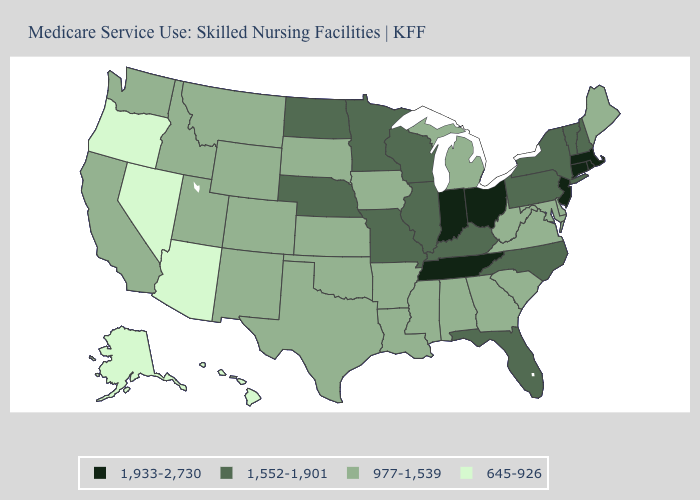Name the states that have a value in the range 1,933-2,730?
Write a very short answer. Connecticut, Indiana, Massachusetts, New Jersey, Ohio, Rhode Island, Tennessee. What is the value of Pennsylvania?
Concise answer only. 1,552-1,901. What is the value of Missouri?
Concise answer only. 1,552-1,901. How many symbols are there in the legend?
Concise answer only. 4. Does Illinois have the same value as Kentucky?
Give a very brief answer. Yes. How many symbols are there in the legend?
Keep it brief. 4. Name the states that have a value in the range 977-1,539?
Give a very brief answer. Alabama, Arkansas, California, Colorado, Delaware, Georgia, Idaho, Iowa, Kansas, Louisiana, Maine, Maryland, Michigan, Mississippi, Montana, New Mexico, Oklahoma, South Carolina, South Dakota, Texas, Utah, Virginia, Washington, West Virginia, Wyoming. What is the highest value in the South ?
Answer briefly. 1,933-2,730. Which states have the highest value in the USA?
Keep it brief. Connecticut, Indiana, Massachusetts, New Jersey, Ohio, Rhode Island, Tennessee. What is the highest value in the USA?
Write a very short answer. 1,933-2,730. What is the lowest value in the USA?
Quick response, please. 645-926. Name the states that have a value in the range 977-1,539?
Answer briefly. Alabama, Arkansas, California, Colorado, Delaware, Georgia, Idaho, Iowa, Kansas, Louisiana, Maine, Maryland, Michigan, Mississippi, Montana, New Mexico, Oklahoma, South Carolina, South Dakota, Texas, Utah, Virginia, Washington, West Virginia, Wyoming. Does Arkansas have a lower value than Illinois?
Quick response, please. Yes. Which states have the highest value in the USA?
Give a very brief answer. Connecticut, Indiana, Massachusetts, New Jersey, Ohio, Rhode Island, Tennessee. 